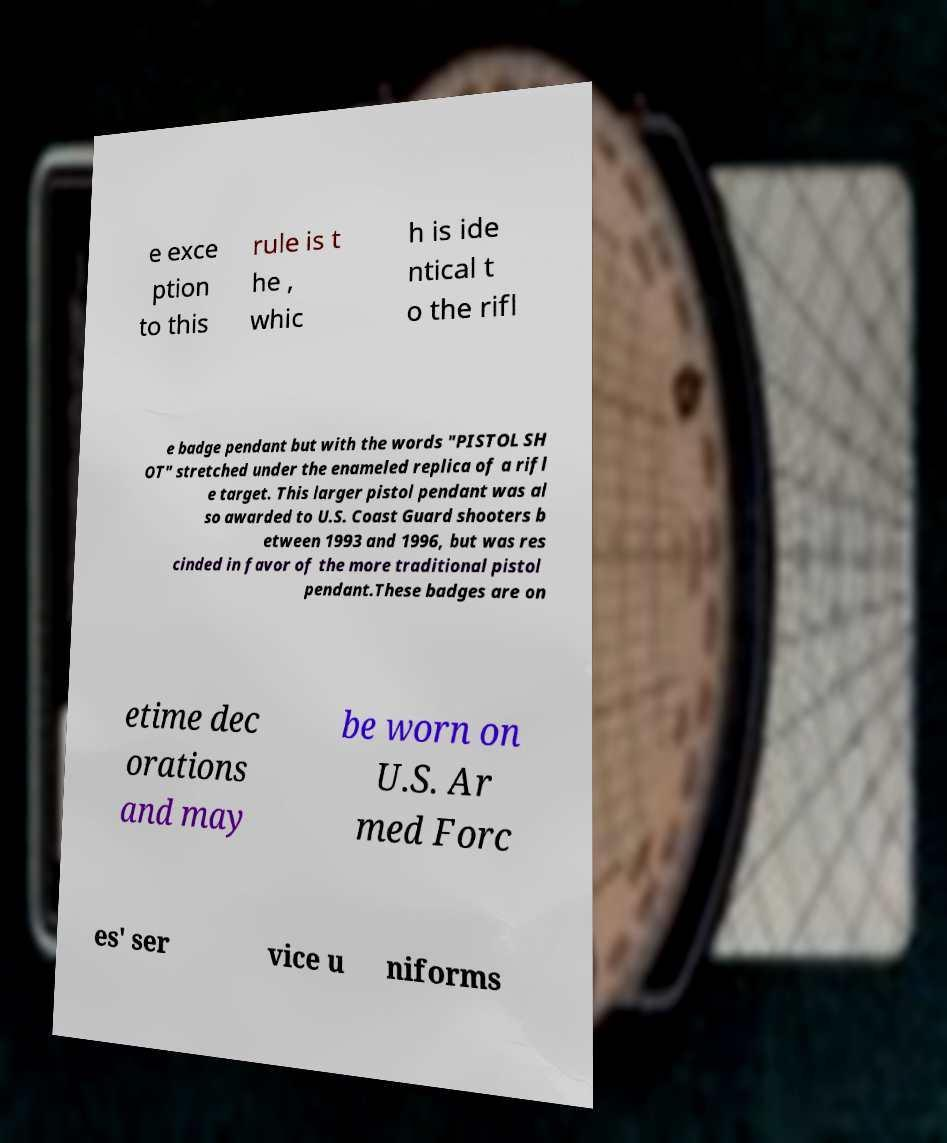What messages or text are displayed in this image? I need them in a readable, typed format. e exce ption to this rule is t he , whic h is ide ntical t o the rifl e badge pendant but with the words "PISTOL SH OT" stretched under the enameled replica of a rifl e target. This larger pistol pendant was al so awarded to U.S. Coast Guard shooters b etween 1993 and 1996, but was res cinded in favor of the more traditional pistol pendant.These badges are on etime dec orations and may be worn on U.S. Ar med Forc es' ser vice u niforms 